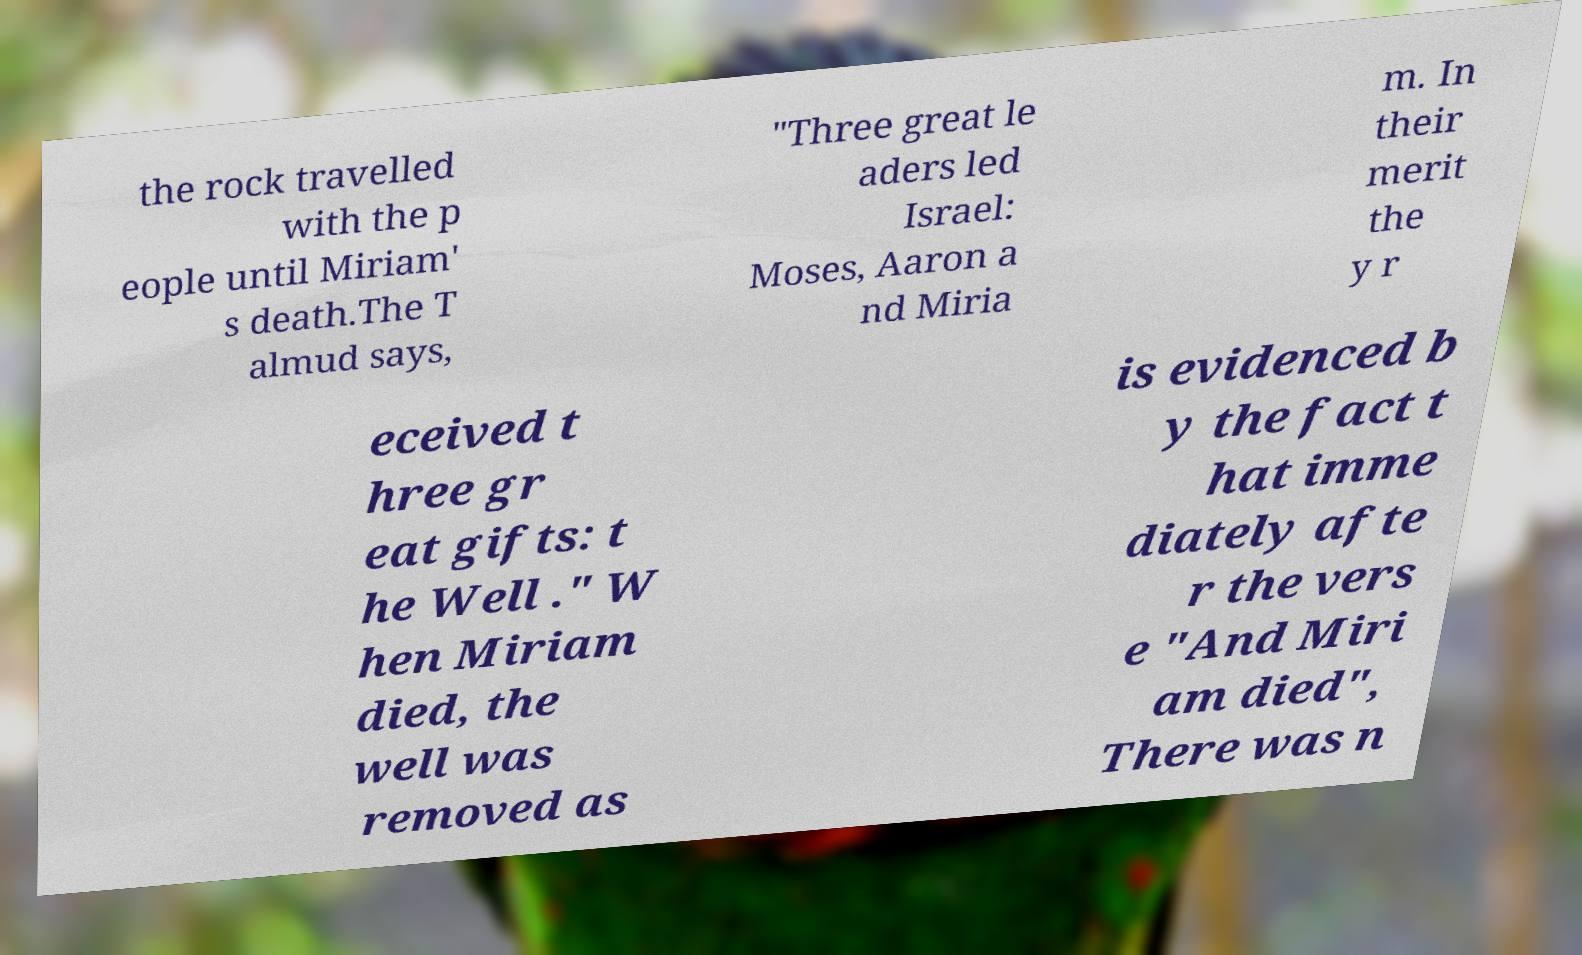Can you read and provide the text displayed in the image?This photo seems to have some interesting text. Can you extract and type it out for me? the rock travelled with the p eople until Miriam' s death.The T almud says, "Three great le aders led Israel: Moses, Aaron a nd Miria m. In their merit the y r eceived t hree gr eat gifts: t he Well ." W hen Miriam died, the well was removed as is evidenced b y the fact t hat imme diately afte r the vers e "And Miri am died", There was n 